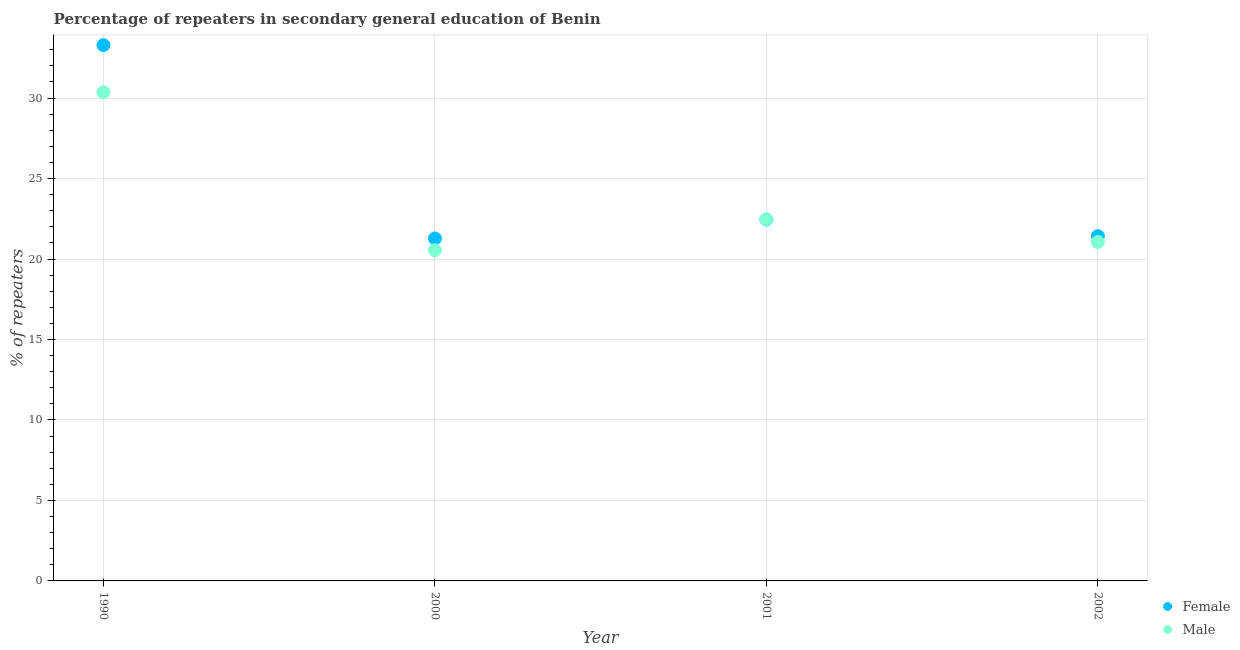How many different coloured dotlines are there?
Make the answer very short. 2. What is the percentage of male repeaters in 2001?
Keep it short and to the point. 22.46. Across all years, what is the maximum percentage of male repeaters?
Ensure brevity in your answer.  30.36. Across all years, what is the minimum percentage of male repeaters?
Ensure brevity in your answer.  20.54. In which year was the percentage of male repeaters maximum?
Ensure brevity in your answer.  1990. In which year was the percentage of female repeaters minimum?
Provide a short and direct response. 2000. What is the total percentage of female repeaters in the graph?
Offer a terse response. 98.43. What is the difference between the percentage of male repeaters in 1990 and that in 2002?
Offer a terse response. 9.3. What is the difference between the percentage of male repeaters in 1990 and the percentage of female repeaters in 2002?
Your answer should be compact. 8.94. What is the average percentage of female repeaters per year?
Give a very brief answer. 24.61. In the year 2000, what is the difference between the percentage of female repeaters and percentage of male repeaters?
Keep it short and to the point. 0.73. What is the ratio of the percentage of male repeaters in 1990 to that in 2001?
Offer a very short reply. 1.35. Is the percentage of female repeaters in 1990 less than that in 2000?
Make the answer very short. No. Is the difference between the percentage of male repeaters in 2001 and 2002 greater than the difference between the percentage of female repeaters in 2001 and 2002?
Offer a very short reply. Yes. What is the difference between the highest and the second highest percentage of male repeaters?
Offer a very short reply. 7.9. What is the difference between the highest and the lowest percentage of male repeaters?
Make the answer very short. 9.82. Is the sum of the percentage of female repeaters in 2001 and 2002 greater than the maximum percentage of male repeaters across all years?
Your answer should be very brief. Yes. Does the percentage of male repeaters monotonically increase over the years?
Provide a short and direct response. No. Is the percentage of male repeaters strictly less than the percentage of female repeaters over the years?
Offer a terse response. No. How many dotlines are there?
Offer a very short reply. 2. Are the values on the major ticks of Y-axis written in scientific E-notation?
Offer a very short reply. No. Does the graph contain any zero values?
Your answer should be very brief. No. How are the legend labels stacked?
Give a very brief answer. Vertical. What is the title of the graph?
Keep it short and to the point. Percentage of repeaters in secondary general education of Benin. What is the label or title of the X-axis?
Keep it short and to the point. Year. What is the label or title of the Y-axis?
Your answer should be very brief. % of repeaters. What is the % of repeaters of Female in 1990?
Make the answer very short. 33.29. What is the % of repeaters of Male in 1990?
Offer a very short reply. 30.36. What is the % of repeaters in Female in 2000?
Your answer should be compact. 21.28. What is the % of repeaters of Male in 2000?
Keep it short and to the point. 20.54. What is the % of repeaters in Female in 2001?
Offer a very short reply. 22.45. What is the % of repeaters in Male in 2001?
Provide a short and direct response. 22.46. What is the % of repeaters of Female in 2002?
Give a very brief answer. 21.42. What is the % of repeaters of Male in 2002?
Provide a succinct answer. 21.06. Across all years, what is the maximum % of repeaters of Female?
Your answer should be very brief. 33.29. Across all years, what is the maximum % of repeaters in Male?
Keep it short and to the point. 30.36. Across all years, what is the minimum % of repeaters in Female?
Provide a succinct answer. 21.28. Across all years, what is the minimum % of repeaters of Male?
Your answer should be compact. 20.54. What is the total % of repeaters of Female in the graph?
Ensure brevity in your answer.  98.43. What is the total % of repeaters of Male in the graph?
Provide a short and direct response. 94.42. What is the difference between the % of repeaters of Female in 1990 and that in 2000?
Offer a terse response. 12.01. What is the difference between the % of repeaters in Male in 1990 and that in 2000?
Give a very brief answer. 9.82. What is the difference between the % of repeaters in Female in 1990 and that in 2001?
Offer a very short reply. 10.84. What is the difference between the % of repeaters in Male in 1990 and that in 2001?
Keep it short and to the point. 7.9. What is the difference between the % of repeaters of Female in 1990 and that in 2002?
Your response must be concise. 11.87. What is the difference between the % of repeaters in Male in 1990 and that in 2002?
Your response must be concise. 9.3. What is the difference between the % of repeaters of Female in 2000 and that in 2001?
Offer a terse response. -1.17. What is the difference between the % of repeaters of Male in 2000 and that in 2001?
Make the answer very short. -1.92. What is the difference between the % of repeaters in Female in 2000 and that in 2002?
Offer a terse response. -0.14. What is the difference between the % of repeaters of Male in 2000 and that in 2002?
Make the answer very short. -0.52. What is the difference between the % of repeaters in Female in 2001 and that in 2002?
Your answer should be compact. 1.03. What is the difference between the % of repeaters of Male in 2001 and that in 2002?
Keep it short and to the point. 1.4. What is the difference between the % of repeaters of Female in 1990 and the % of repeaters of Male in 2000?
Provide a succinct answer. 12.75. What is the difference between the % of repeaters in Female in 1990 and the % of repeaters in Male in 2001?
Provide a short and direct response. 10.83. What is the difference between the % of repeaters of Female in 1990 and the % of repeaters of Male in 2002?
Offer a terse response. 12.23. What is the difference between the % of repeaters in Female in 2000 and the % of repeaters in Male in 2001?
Make the answer very short. -1.19. What is the difference between the % of repeaters in Female in 2000 and the % of repeaters in Male in 2002?
Make the answer very short. 0.22. What is the difference between the % of repeaters in Female in 2001 and the % of repeaters in Male in 2002?
Make the answer very short. 1.39. What is the average % of repeaters of Female per year?
Ensure brevity in your answer.  24.61. What is the average % of repeaters in Male per year?
Your response must be concise. 23.6. In the year 1990, what is the difference between the % of repeaters in Female and % of repeaters in Male?
Give a very brief answer. 2.93. In the year 2000, what is the difference between the % of repeaters in Female and % of repeaters in Male?
Provide a short and direct response. 0.73. In the year 2001, what is the difference between the % of repeaters in Female and % of repeaters in Male?
Provide a succinct answer. -0.01. In the year 2002, what is the difference between the % of repeaters of Female and % of repeaters of Male?
Ensure brevity in your answer.  0.36. What is the ratio of the % of repeaters of Female in 1990 to that in 2000?
Keep it short and to the point. 1.56. What is the ratio of the % of repeaters in Male in 1990 to that in 2000?
Your answer should be compact. 1.48. What is the ratio of the % of repeaters in Female in 1990 to that in 2001?
Ensure brevity in your answer.  1.48. What is the ratio of the % of repeaters of Male in 1990 to that in 2001?
Your answer should be compact. 1.35. What is the ratio of the % of repeaters in Female in 1990 to that in 2002?
Offer a very short reply. 1.55. What is the ratio of the % of repeaters of Male in 1990 to that in 2002?
Your answer should be compact. 1.44. What is the ratio of the % of repeaters of Female in 2000 to that in 2001?
Your answer should be compact. 0.95. What is the ratio of the % of repeaters of Male in 2000 to that in 2001?
Offer a very short reply. 0.91. What is the ratio of the % of repeaters of Female in 2000 to that in 2002?
Your response must be concise. 0.99. What is the ratio of the % of repeaters of Male in 2000 to that in 2002?
Offer a very short reply. 0.98. What is the ratio of the % of repeaters in Female in 2001 to that in 2002?
Give a very brief answer. 1.05. What is the ratio of the % of repeaters in Male in 2001 to that in 2002?
Offer a very short reply. 1.07. What is the difference between the highest and the second highest % of repeaters of Female?
Offer a very short reply. 10.84. What is the difference between the highest and the second highest % of repeaters of Male?
Your answer should be compact. 7.9. What is the difference between the highest and the lowest % of repeaters in Female?
Offer a terse response. 12.01. What is the difference between the highest and the lowest % of repeaters of Male?
Your answer should be compact. 9.82. 